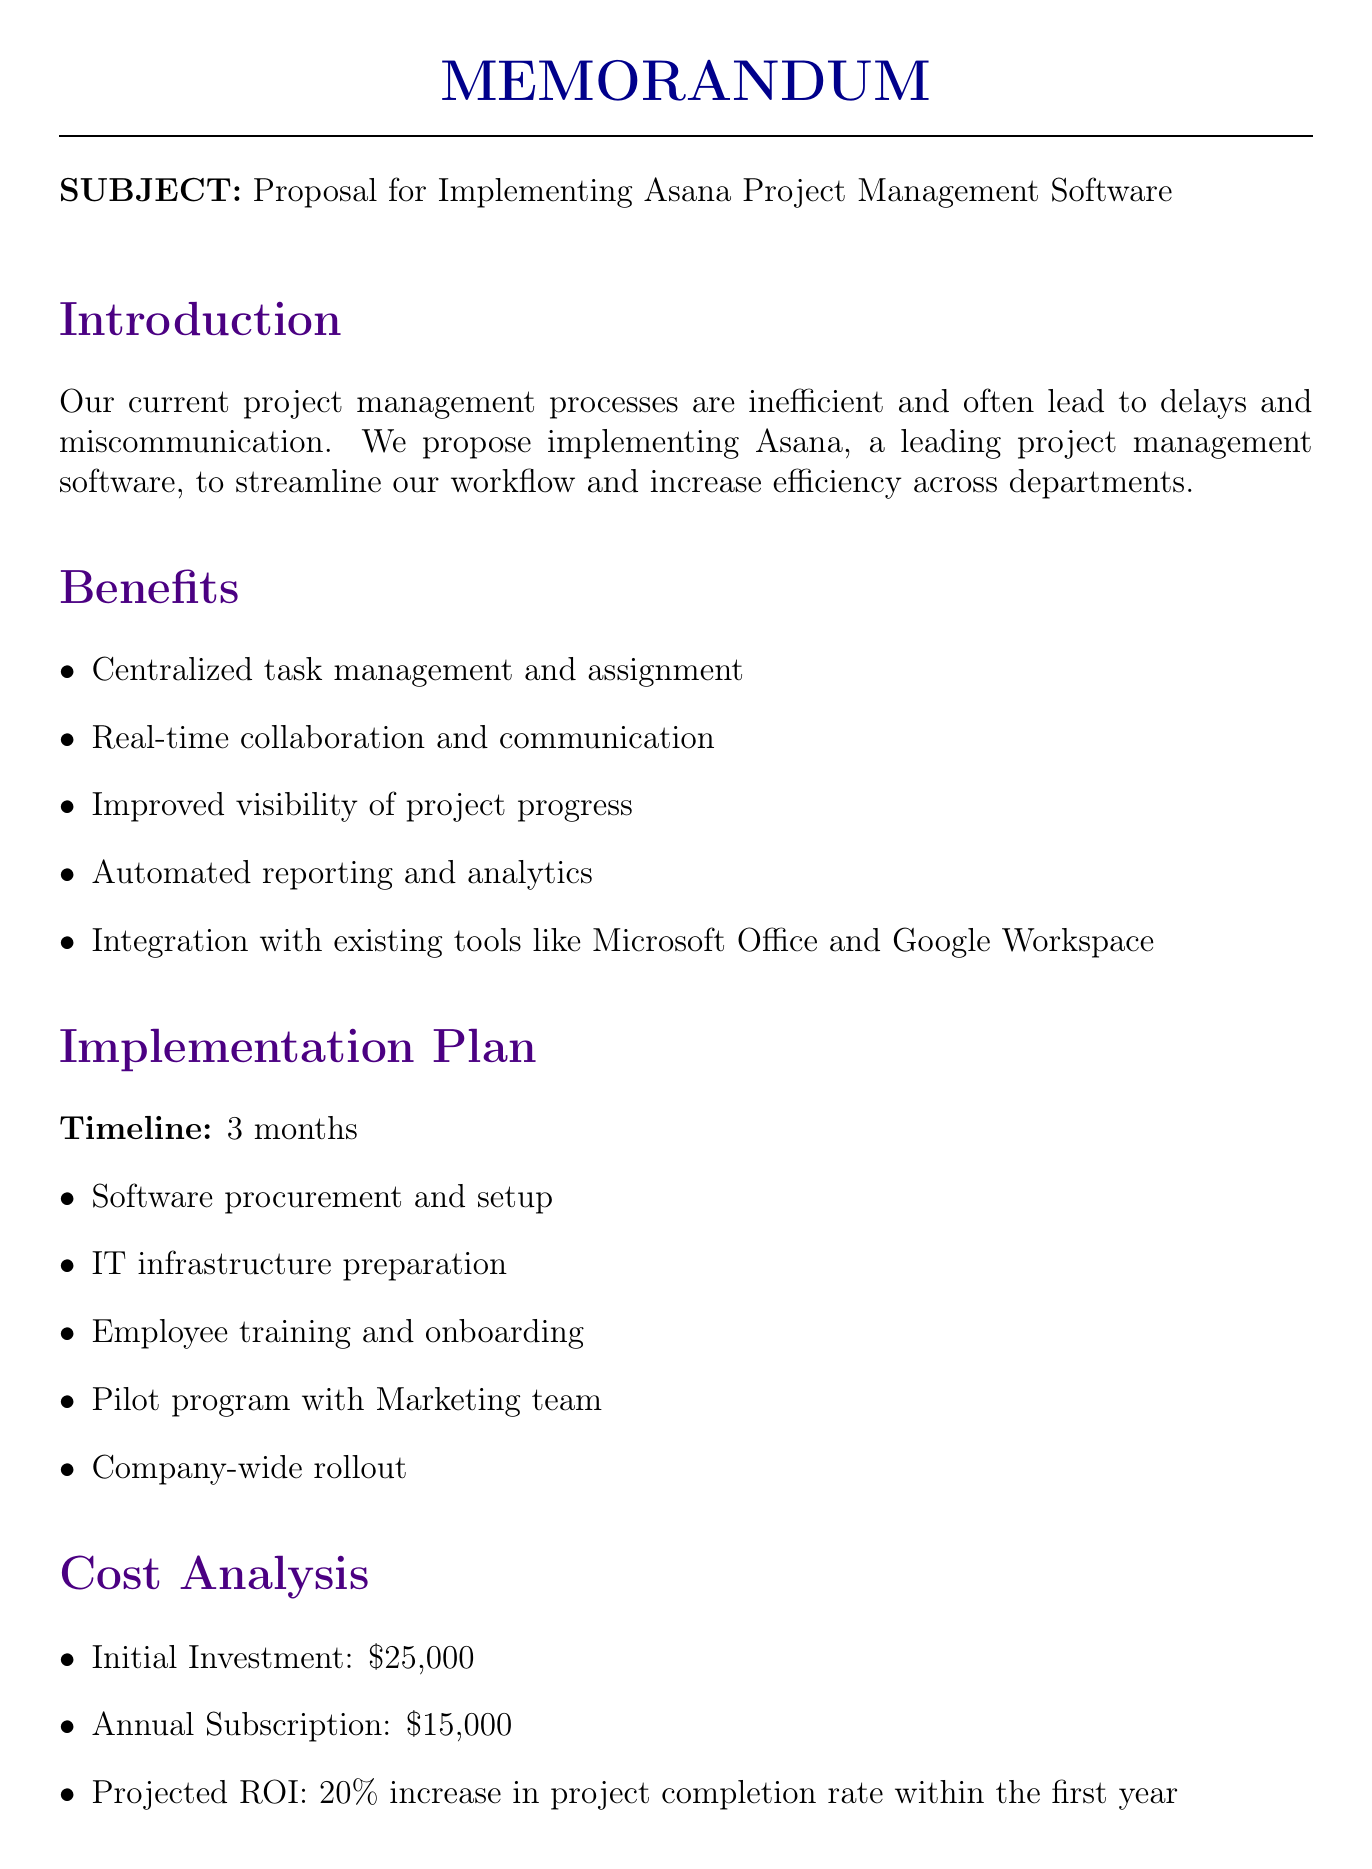What is the proposed software? The document explicitly states the proposal to implement Asana as the project management software.
Answer: Asana What is the initial investment cost? The document provides a clear figure for the initial investment needed for implementing the software, which is $25,000.
Answer: $25,000 How long is the timeline for implementation? The proposal mentions a total timeline duration for the implementation phase being 3 months.
Answer: 3 months What is one of the potential challenges identified? The document lists multiple potential challenges, one of which is "Initial resistance to change from some employees."
Answer: Initial resistance to change from some employees What is the projected ROI? The document states a projected ROI of a specific percentage increase in project completion rates within the first year.
Answer: 20% increase in project completion rate within the first year Who are the key stakeholders in the implementation plan? The proposal lists key stakeholders involved in the implementation, including the IT Department and Human Resources.
Answer: IT Department, Human Resources, Department Heads, Project Managers What approach is taken for change management? The document outlines the approach to be a gradual implementation with continuous support and feedback loops.
Answer: Gradual implementation with continuous support and feedback loops What is one of the success metrics mentioned? The document identifies several success metrics, including a reduction in project delays.
Answer: Reduction in project delays 